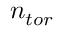<formula> <loc_0><loc_0><loc_500><loc_500>n _ { t o r }</formula> 